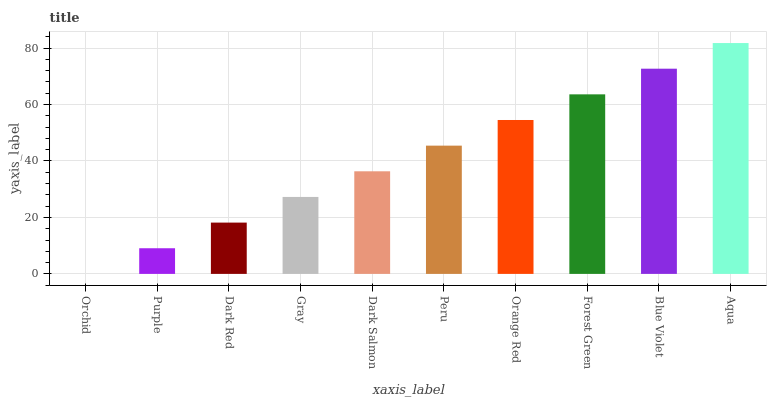Is Orchid the minimum?
Answer yes or no. Yes. Is Aqua the maximum?
Answer yes or no. Yes. Is Purple the minimum?
Answer yes or no. No. Is Purple the maximum?
Answer yes or no. No. Is Purple greater than Orchid?
Answer yes or no. Yes. Is Orchid less than Purple?
Answer yes or no. Yes. Is Orchid greater than Purple?
Answer yes or no. No. Is Purple less than Orchid?
Answer yes or no. No. Is Peru the high median?
Answer yes or no. Yes. Is Dark Salmon the low median?
Answer yes or no. Yes. Is Purple the high median?
Answer yes or no. No. Is Peru the low median?
Answer yes or no. No. 